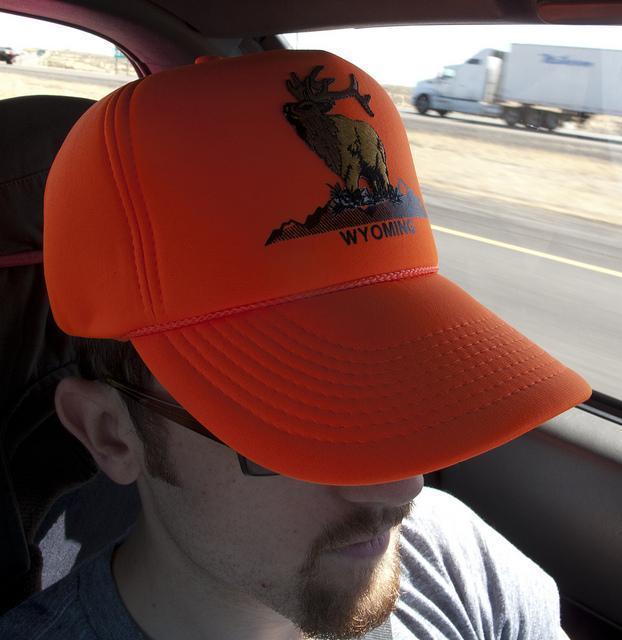How many people are visible?
Give a very brief answer. 1. How many cars are parked in the background?
Give a very brief answer. 0. 